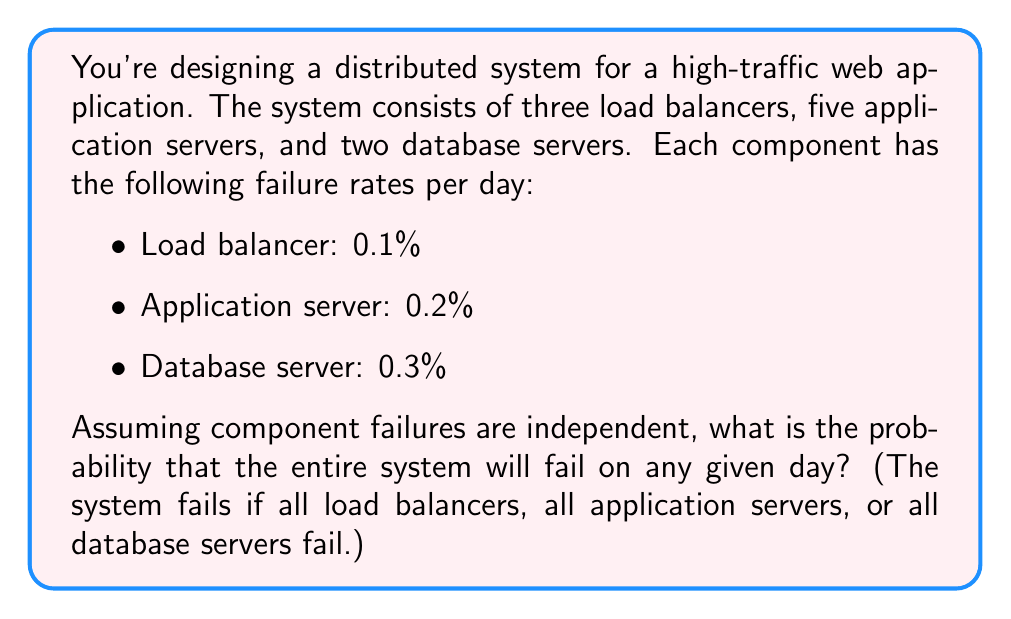Solve this math problem. Let's approach this step-by-step:

1) First, we need to calculate the probability of each component type failing completely:

   a) For load balancers:
      $P(\text{all load balancers fail}) = 0.001^3 = 10^{-9}$

   b) For application servers:
      $P(\text{all application servers fail}) = 0.002^5 = 3.2 \times 10^{-14}$

   c) For database servers:
      $P(\text{all database servers fail}) = 0.003^2 = 9 \times 10^{-6}$

2) The system fails if any of these events occur. To find the probability of at least one of these events occurring, we can use the complement of the probability that none of them occur:

   $P(\text{system fails}) = 1 - P(\text{no component type fails completely})$

3) The probability that no component type fails completely is the product of the probabilities that each component type doesn't fail completely:

   $P(\text{no component type fails completely}) = (1 - 10^{-9})(1 - 3.2 \times 10^{-14})(1 - 9 \times 10^{-6})$

4) Simplifying:
   $\approx 1 - 9 \times 10^{-6}$ (as the other terms are negligibly small)

5) Therefore:
   $P(\text{system fails}) \approx 1 - (1 - 9 \times 10^{-6}) = 9 \times 10^{-6}$
Answer: $9 \times 10^{-6}$ or 0.0009% 